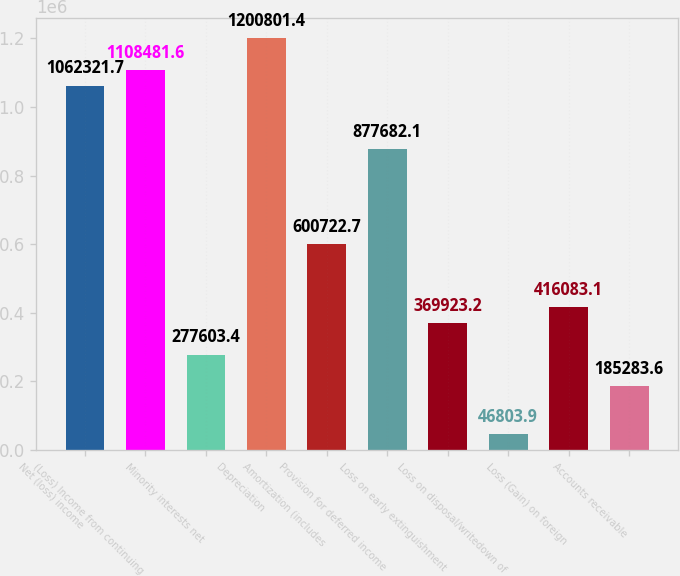<chart> <loc_0><loc_0><loc_500><loc_500><bar_chart><fcel>Net (loss) income<fcel>(Loss) Income from continuing<fcel>Minority interests net<fcel>Depreciation<fcel>Amortization (includes<fcel>Provision for deferred income<fcel>Loss on early extinguishment<fcel>Loss on disposal/writedown of<fcel>Loss (Gain) on foreign<fcel>Accounts receivable<nl><fcel>1.06232e+06<fcel>1.10848e+06<fcel>277603<fcel>1.2008e+06<fcel>600723<fcel>877682<fcel>369923<fcel>46803.9<fcel>416083<fcel>185284<nl></chart> 